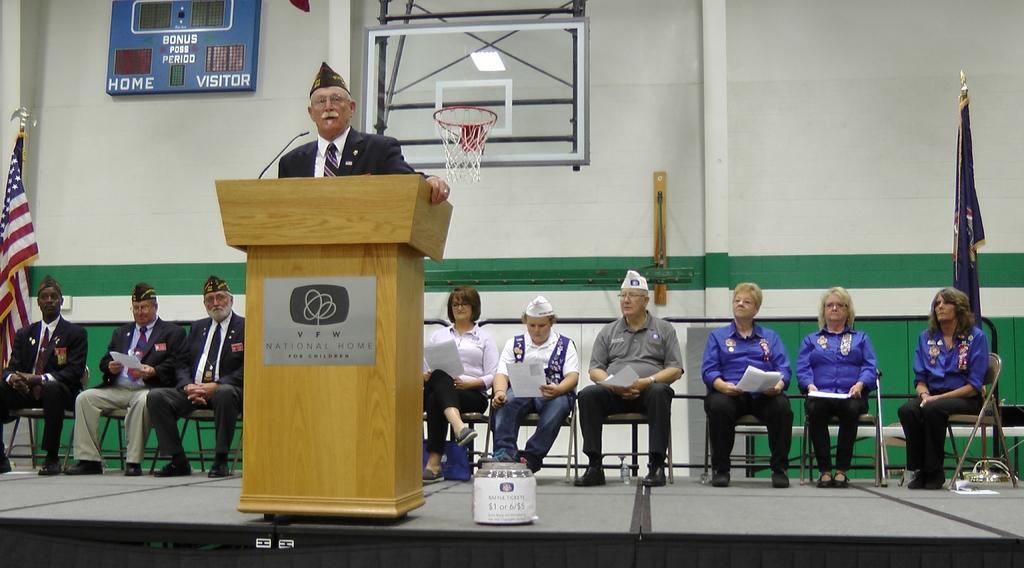Describe this image in one or two sentences. In this image in the front there is a man standing and in front of the man there is a podium and on the podium there is some text written on it and there is a mic on the podium. In the background there are persons sitting on a chair and holding papers in their hand and there is a basketball net and there are flags and on the wall there is a board with some text written on it 